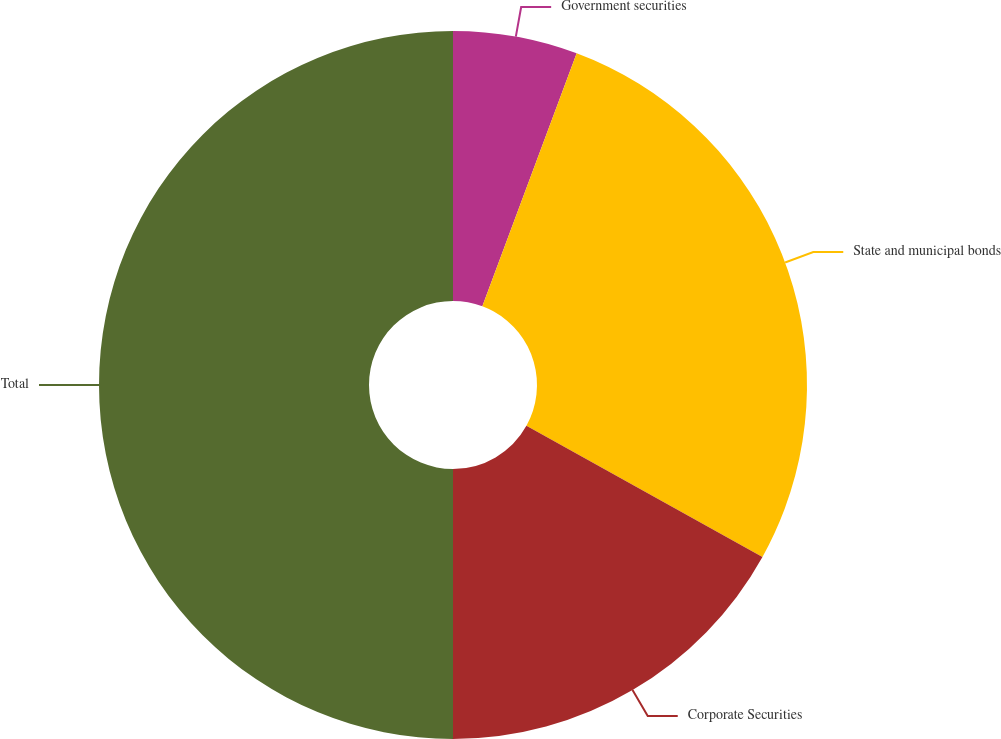Convert chart. <chart><loc_0><loc_0><loc_500><loc_500><pie_chart><fcel>Government securities<fcel>State and municipal bonds<fcel>Corporate Securities<fcel>Total<nl><fcel>5.68%<fcel>27.39%<fcel>16.93%<fcel>50.0%<nl></chart> 